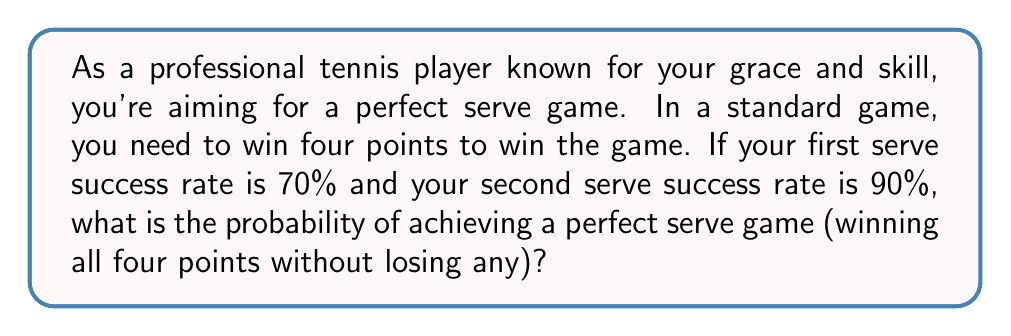Can you answer this question? Let's approach this step-by-step:

1) For each point, you have two chances to serve:
   - First serve with 70% success rate
   - If first serve fails, second serve with 90% success rate

2) The probability of winning a single point is:
   $P(\text{win point}) = 0.70 + (1 - 0.70) \times 0.90 = 0.70 + 0.30 \times 0.90 = 0.97$

3) To achieve a perfect serve game, you need to win all four points consecutively. Since each point is an independent event, we multiply the probabilities:

   $P(\text{perfect game}) = P(\text{win point})^4 = 0.97^4$

4) Calculate the final probability:
   $P(\text{perfect game}) = 0.97^4 = 0.8853...$ 

5) Convert to percentage:
   $0.8853... \times 100\% \approx 88.53\%$
Answer: The probability of achieving a perfect serve game is approximately $88.53\%$ or $0.8853$. 